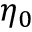<formula> <loc_0><loc_0><loc_500><loc_500>\eta _ { 0 }</formula> 